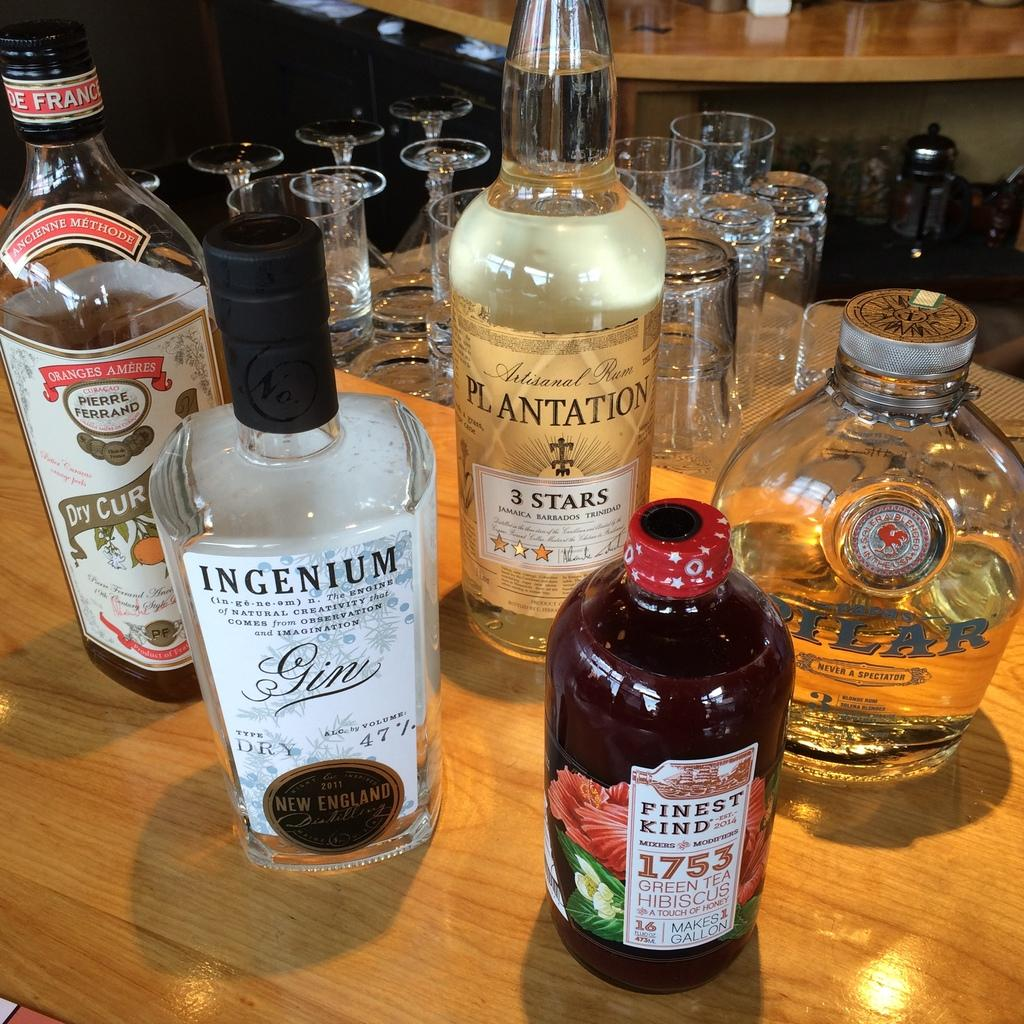What is on the table in the image? There are wine bottles on the table. Can you describe the wine bottles? The wine bottles are of different types. What else can be seen behind the wine bottles? There are glasses behind the wine bottles. How many pairs of shoes are visible in the image? There are no shoes visible in the image; it only features wine bottles and glasses. What type of poison is being served in the wine bottles? There is no indication of poison in the image; the wine bottles contain wine. 